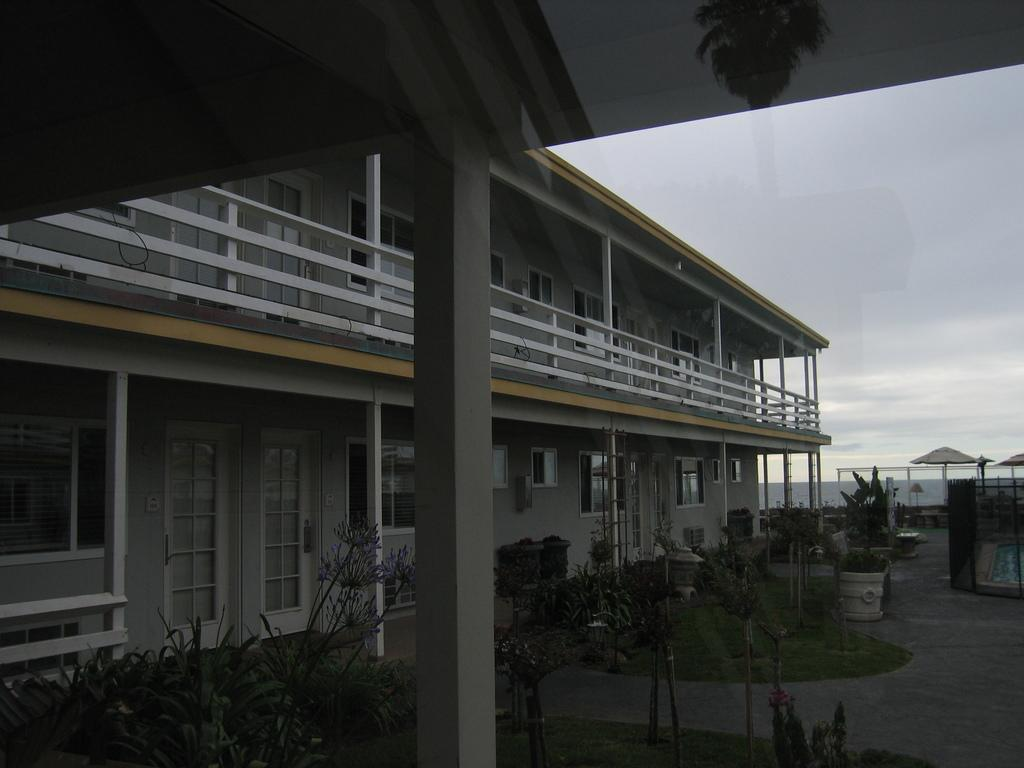What is the main structure in the image? There is a building in the image. What can be seen on the ground near the building? There are plants on the ground. What is visible in the sky in the background of the image? There are clouds visible in the sky in the background of the image. What type of shop can be seen in the image? There is no shop present in the image; it features a building, plants, and clouds in the sky. Can you tell me how much the people in the image hate each other? There are no people present in the image, so it is impossible to determine their feelings towards each other. 